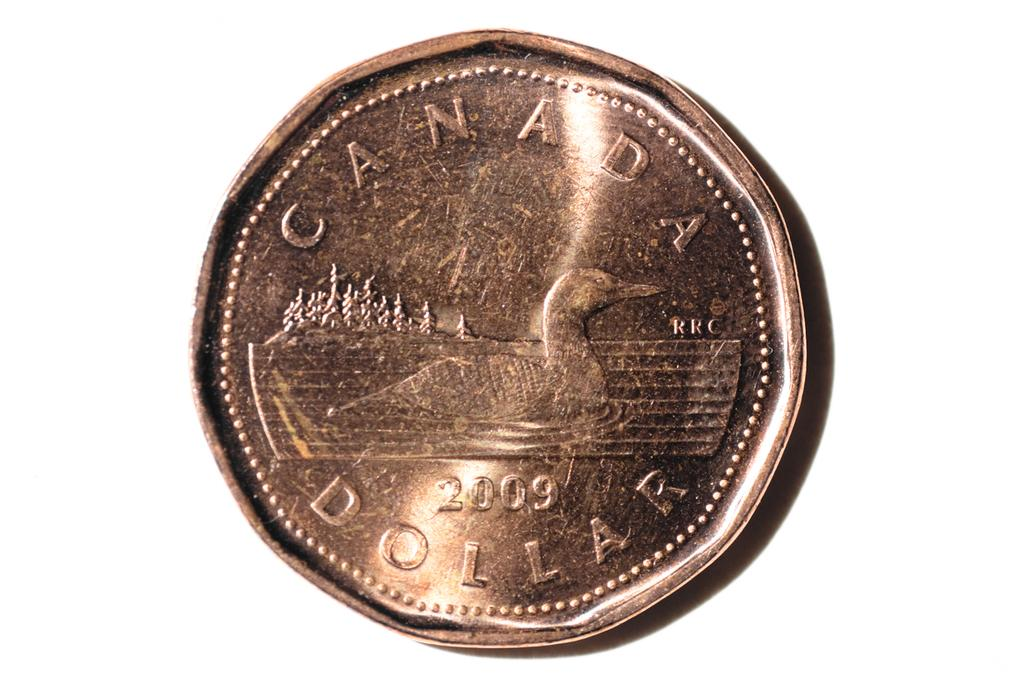<image>
Write a terse but informative summary of the picture. a golden coin that says the word canada dollar on it 